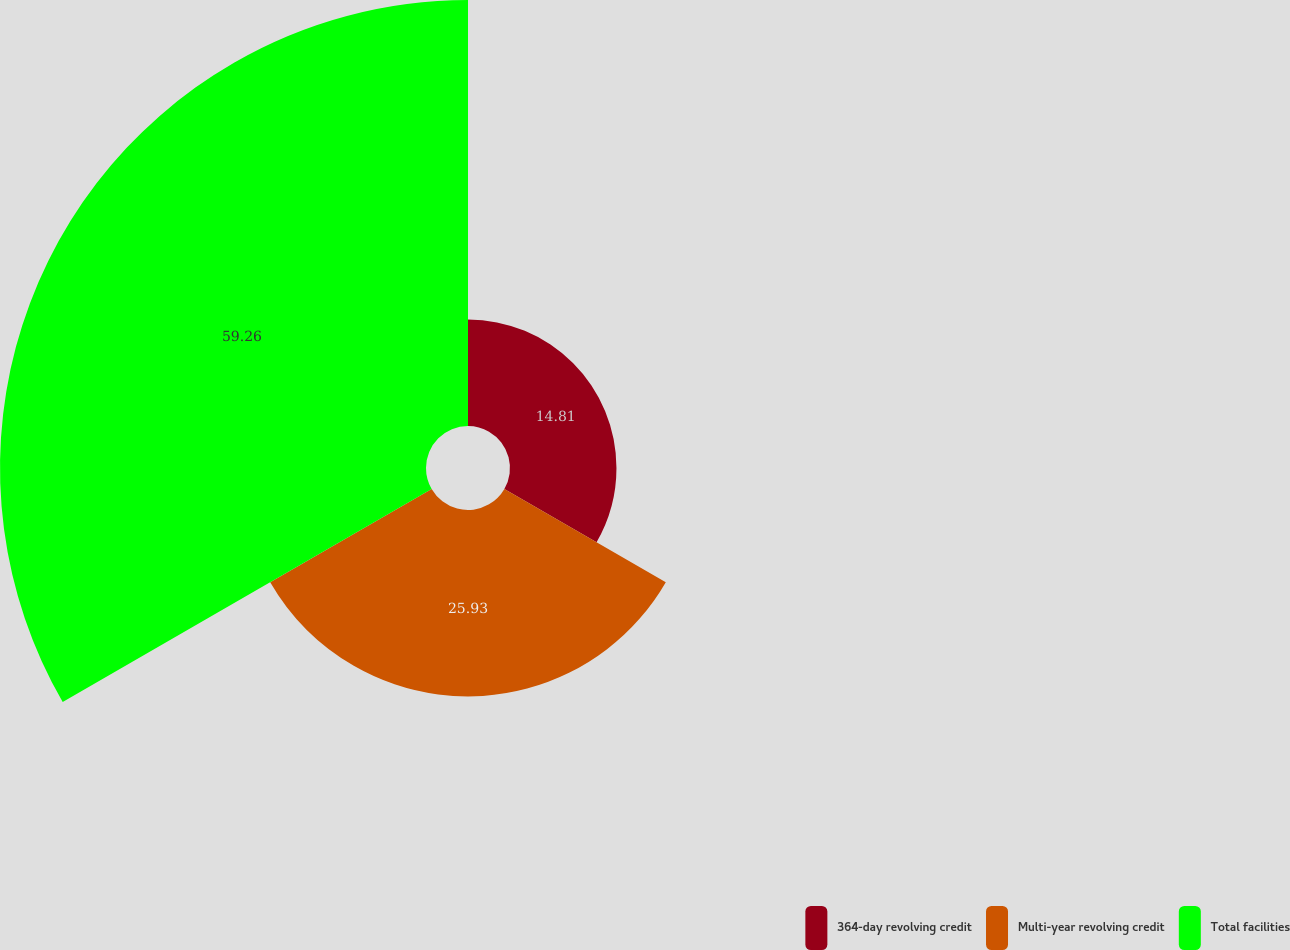<chart> <loc_0><loc_0><loc_500><loc_500><pie_chart><fcel>364-day revolving credit<fcel>Multi-year revolving credit<fcel>Total facilities<nl><fcel>14.81%<fcel>25.93%<fcel>59.26%<nl></chart> 